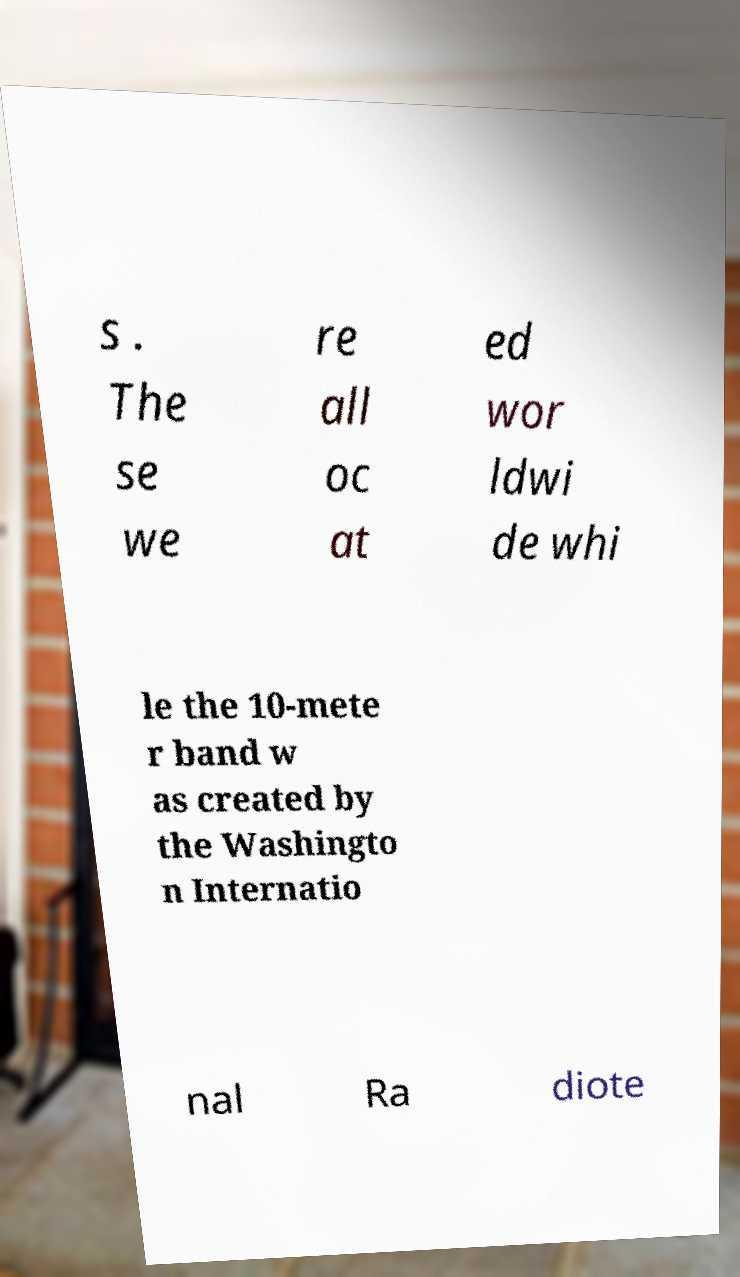Can you read and provide the text displayed in the image?This photo seems to have some interesting text. Can you extract and type it out for me? s . The se we re all oc at ed wor ldwi de whi le the 10-mete r band w as created by the Washingto n Internatio nal Ra diote 